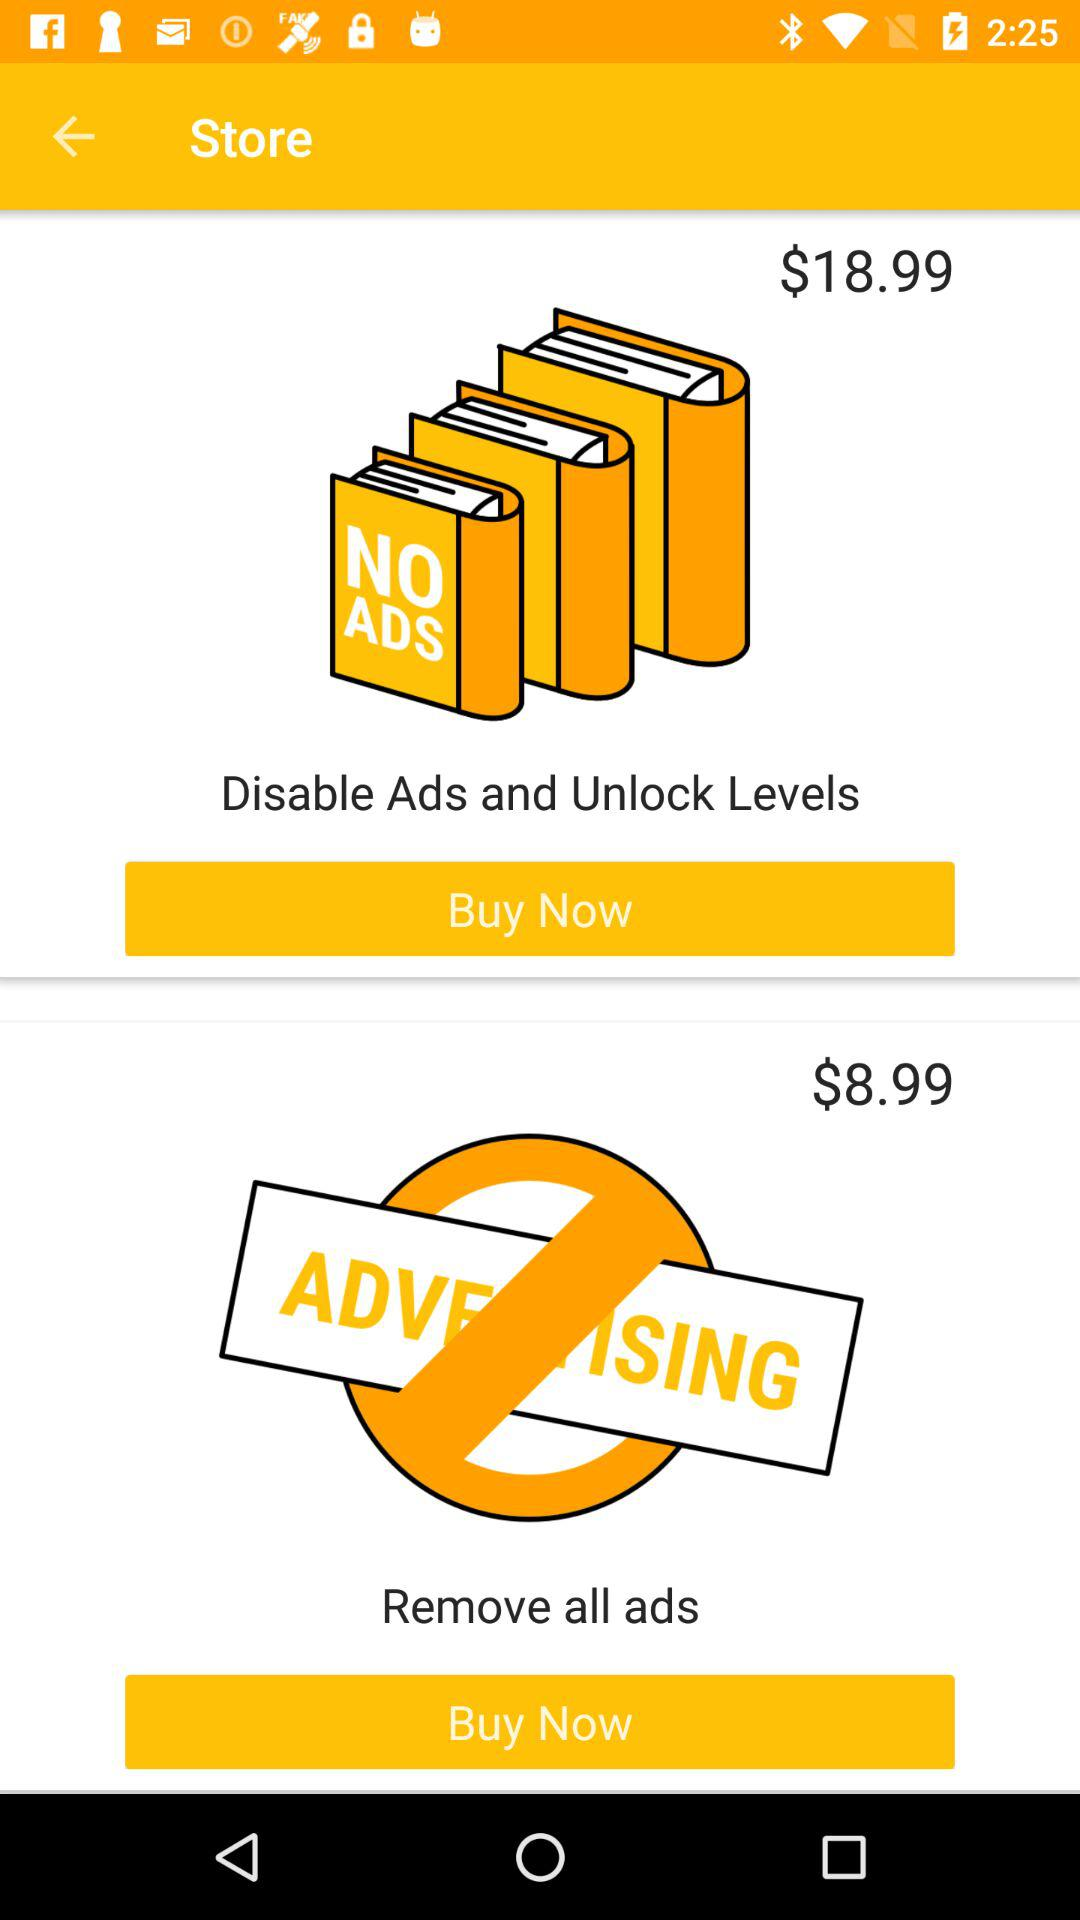How much more does the 'Disable Ads and Unlock Levels' item cost than the 'Remove all ads' item?
Answer the question using a single word or phrase. $10.00 